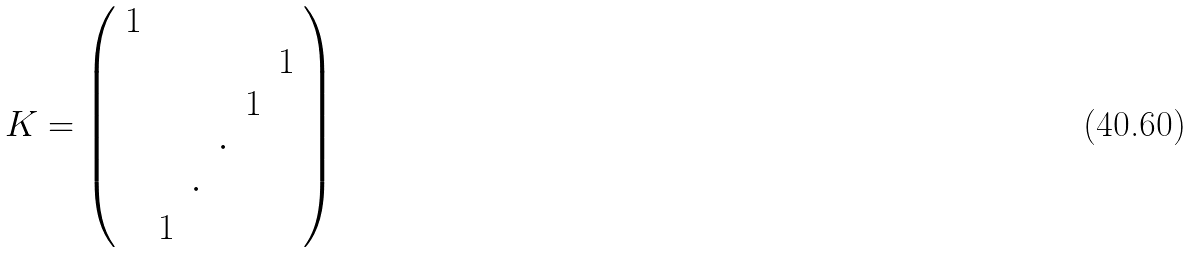<formula> <loc_0><loc_0><loc_500><loc_500>K = \left ( \begin{array} { c c c c c c } 1 & & & & & \\ & & & & & 1 \\ & & & & 1 & \\ & & & \cdot & & \\ & & \cdot & & & \\ & 1 & & & & \end{array} \right )</formula> 